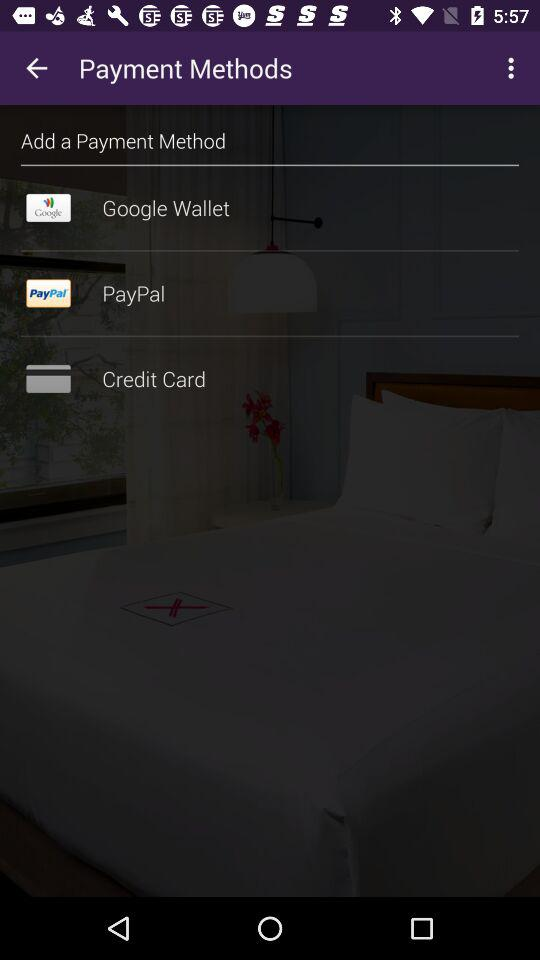How many payment methods are available?
Answer the question using a single word or phrase. 3 